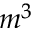<formula> <loc_0><loc_0><loc_500><loc_500>m ^ { 3 }</formula> 